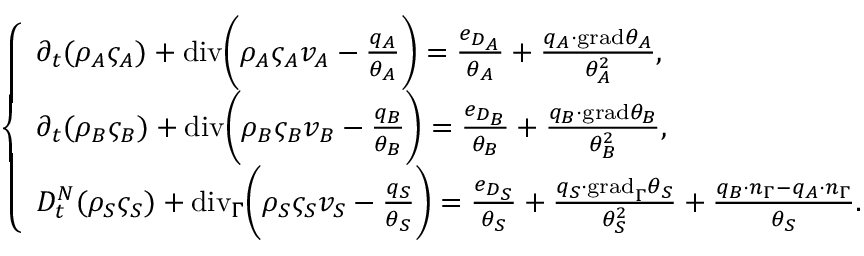<formula> <loc_0><loc_0><loc_500><loc_500>\left \{ \begin{array} { l l } { \partial _ { t } ( \rho _ { A } \varsigma _ { A } ) + { d i v } \left ( \rho _ { A } \varsigma _ { A } v _ { A } - \frac { q _ { A } } { \theta _ { A } } \right ) = \frac { e _ { D _ { A } } } { \theta _ { A } } + \frac { q _ { A } \cdot { g r a d } \theta _ { A } } { \theta _ { A } ^ { 2 } } , } \\ { \partial _ { t } ( \rho _ { B } \varsigma _ { B } ) + { d i v } \left ( \rho _ { B } \varsigma _ { B } v _ { B } - \frac { q _ { B } } { \theta _ { B } } \right ) = \frac { e _ { D _ { B } } } { \theta _ { B } } + \frac { q _ { B } \cdot { g r a d } \theta _ { B } } { \theta _ { B } ^ { 2 } } , } \\ { D _ { t } ^ { N } ( \rho _ { S } \varsigma _ { S } ) + { d i v } _ { \Gamma } \left ( \rho _ { S } \varsigma _ { S } v _ { S } - \frac { q _ { S } } { \theta _ { S } } \right ) = \frac { e _ { D _ { S } } } { \theta _ { S } } + \frac { q _ { S } \cdot { g r a d } _ { \Gamma } \theta _ { S } } { \theta _ { S } ^ { 2 } } + \frac { q _ { B } \cdot n _ { \Gamma } - q _ { A } \cdot n _ { \Gamma } } { \theta _ { S } } . } \end{array}</formula> 